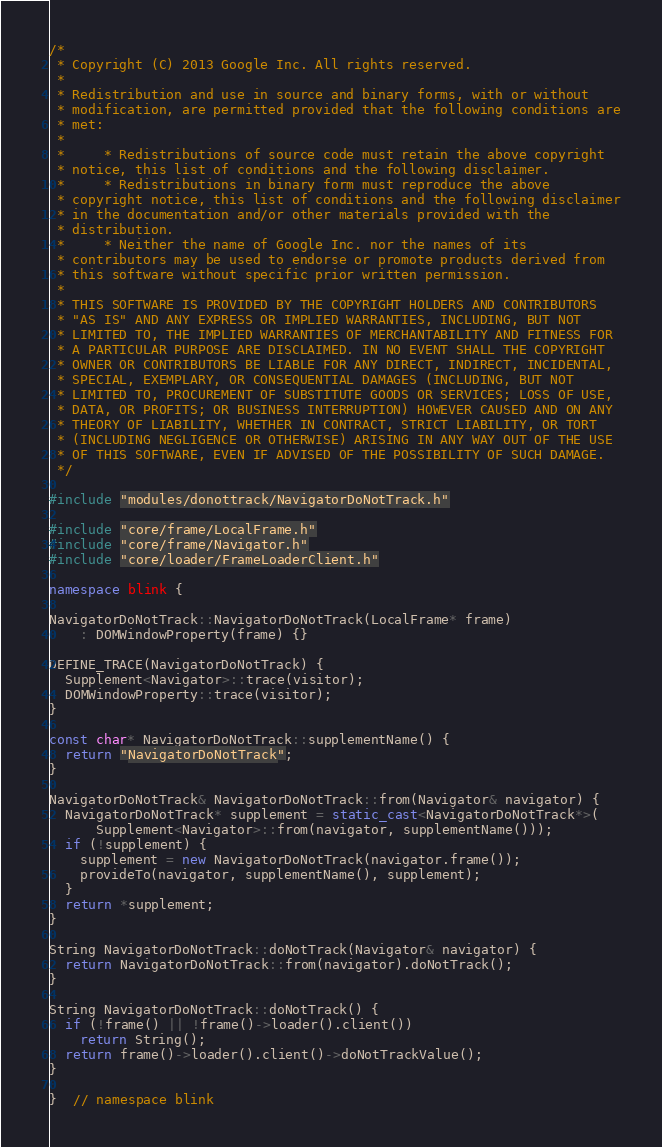<code> <loc_0><loc_0><loc_500><loc_500><_C++_>/*
 * Copyright (C) 2013 Google Inc. All rights reserved.
 *
 * Redistribution and use in source and binary forms, with or without
 * modification, are permitted provided that the following conditions are
 * met:
 *
 *     * Redistributions of source code must retain the above copyright
 * notice, this list of conditions and the following disclaimer.
 *     * Redistributions in binary form must reproduce the above
 * copyright notice, this list of conditions and the following disclaimer
 * in the documentation and/or other materials provided with the
 * distribution.
 *     * Neither the name of Google Inc. nor the names of its
 * contributors may be used to endorse or promote products derived from
 * this software without specific prior written permission.
 *
 * THIS SOFTWARE IS PROVIDED BY THE COPYRIGHT HOLDERS AND CONTRIBUTORS
 * "AS IS" AND ANY EXPRESS OR IMPLIED WARRANTIES, INCLUDING, BUT NOT
 * LIMITED TO, THE IMPLIED WARRANTIES OF MERCHANTABILITY AND FITNESS FOR
 * A PARTICULAR PURPOSE ARE DISCLAIMED. IN NO EVENT SHALL THE COPYRIGHT
 * OWNER OR CONTRIBUTORS BE LIABLE FOR ANY DIRECT, INDIRECT, INCIDENTAL,
 * SPECIAL, EXEMPLARY, OR CONSEQUENTIAL DAMAGES (INCLUDING, BUT NOT
 * LIMITED TO, PROCUREMENT OF SUBSTITUTE GOODS OR SERVICES; LOSS OF USE,
 * DATA, OR PROFITS; OR BUSINESS INTERRUPTION) HOWEVER CAUSED AND ON ANY
 * THEORY OF LIABILITY, WHETHER IN CONTRACT, STRICT LIABILITY, OR TORT
 * (INCLUDING NEGLIGENCE OR OTHERWISE) ARISING IN ANY WAY OUT OF THE USE
 * OF THIS SOFTWARE, EVEN IF ADVISED OF THE POSSIBILITY OF SUCH DAMAGE.
 */

#include "modules/donottrack/NavigatorDoNotTrack.h"

#include "core/frame/LocalFrame.h"
#include "core/frame/Navigator.h"
#include "core/loader/FrameLoaderClient.h"

namespace blink {

NavigatorDoNotTrack::NavigatorDoNotTrack(LocalFrame* frame)
    : DOMWindowProperty(frame) {}

DEFINE_TRACE(NavigatorDoNotTrack) {
  Supplement<Navigator>::trace(visitor);
  DOMWindowProperty::trace(visitor);
}

const char* NavigatorDoNotTrack::supplementName() {
  return "NavigatorDoNotTrack";
}

NavigatorDoNotTrack& NavigatorDoNotTrack::from(Navigator& navigator) {
  NavigatorDoNotTrack* supplement = static_cast<NavigatorDoNotTrack*>(
      Supplement<Navigator>::from(navigator, supplementName()));
  if (!supplement) {
    supplement = new NavigatorDoNotTrack(navigator.frame());
    provideTo(navigator, supplementName(), supplement);
  }
  return *supplement;
}

String NavigatorDoNotTrack::doNotTrack(Navigator& navigator) {
  return NavigatorDoNotTrack::from(navigator).doNotTrack();
}

String NavigatorDoNotTrack::doNotTrack() {
  if (!frame() || !frame()->loader().client())
    return String();
  return frame()->loader().client()->doNotTrackValue();
}

}  // namespace blink
</code> 